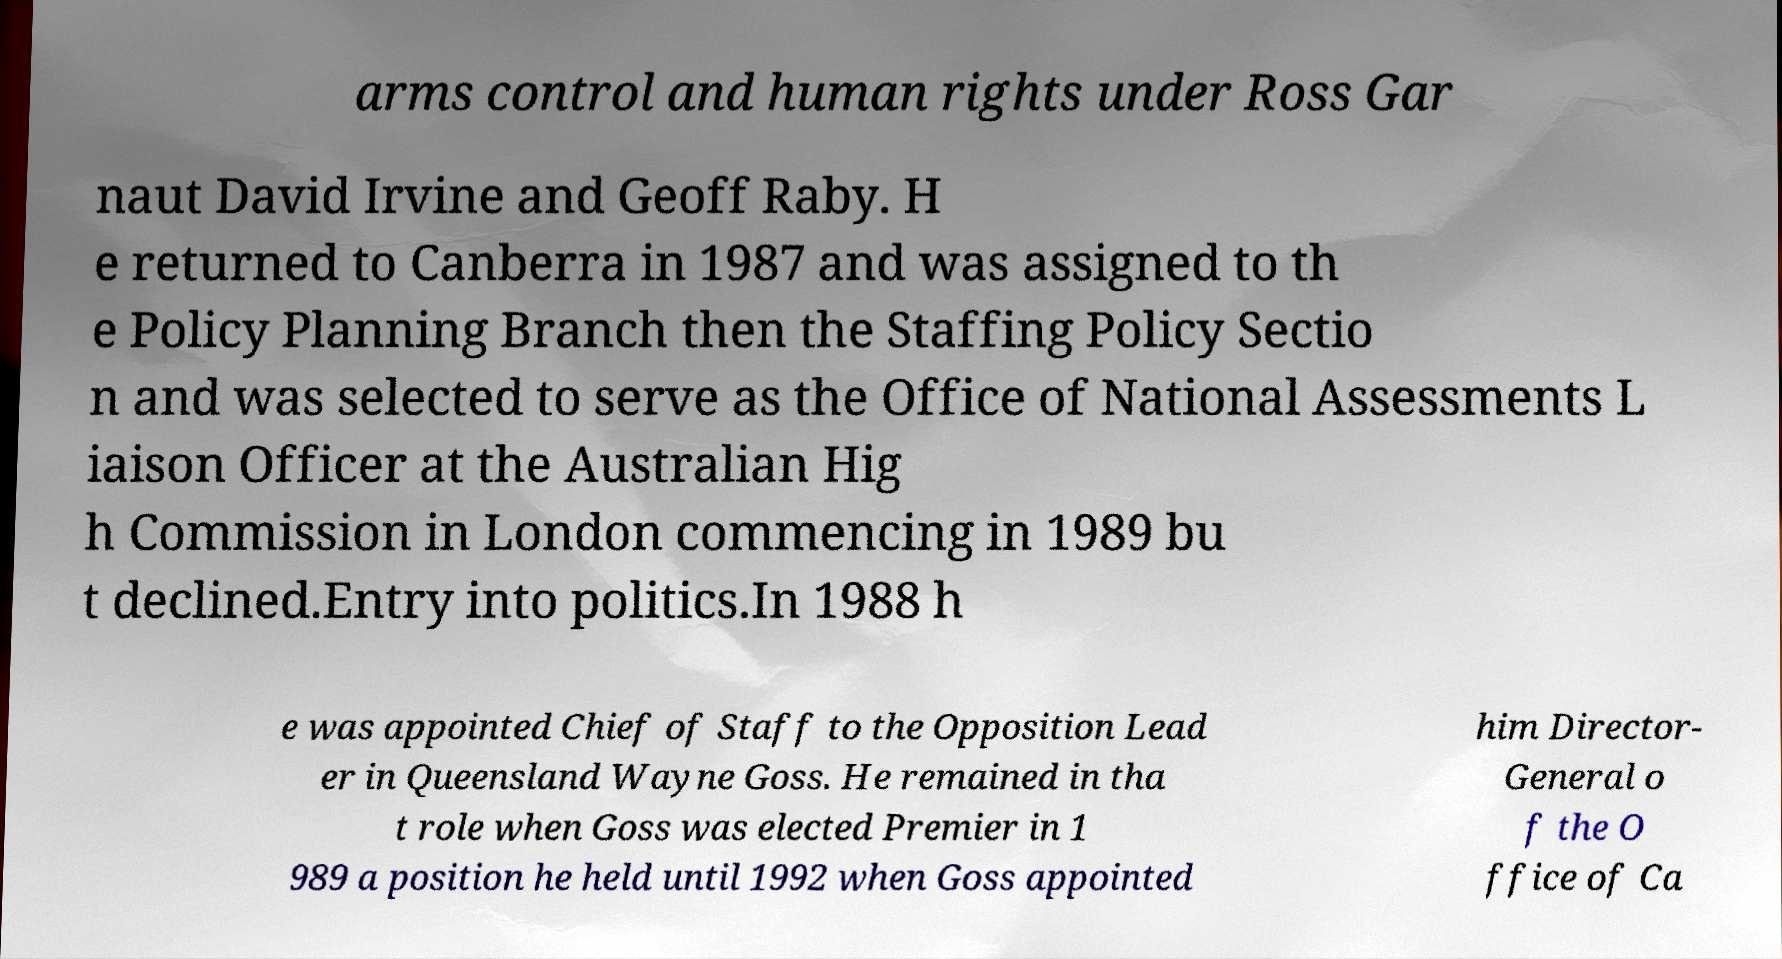Could you assist in decoding the text presented in this image and type it out clearly? arms control and human rights under Ross Gar naut David Irvine and Geoff Raby. H e returned to Canberra in 1987 and was assigned to th e Policy Planning Branch then the Staffing Policy Sectio n and was selected to serve as the Office of National Assessments L iaison Officer at the Australian Hig h Commission in London commencing in 1989 bu t declined.Entry into politics.In 1988 h e was appointed Chief of Staff to the Opposition Lead er in Queensland Wayne Goss. He remained in tha t role when Goss was elected Premier in 1 989 a position he held until 1992 when Goss appointed him Director- General o f the O ffice of Ca 